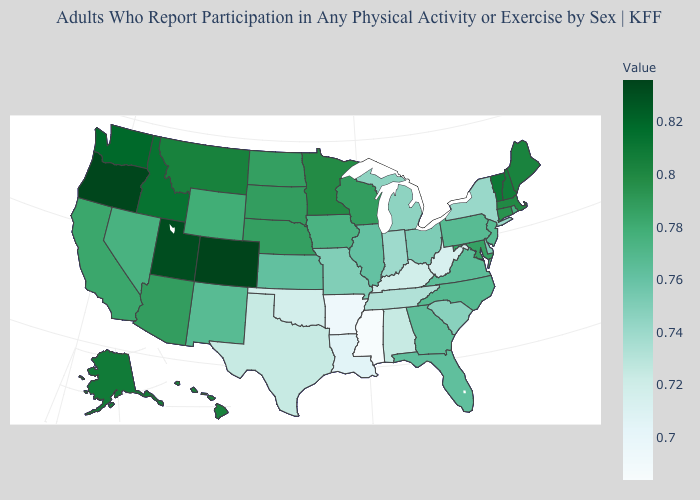Does the map have missing data?
Concise answer only. No. Does Maine have a higher value than Kentucky?
Answer briefly. Yes. Among the states that border Indiana , which have the lowest value?
Keep it brief. Kentucky. Among the states that border Texas , does New Mexico have the highest value?
Quick response, please. Yes. Among the states that border Alabama , does Georgia have the highest value?
Be succinct. Yes. Among the states that border Massachusetts , does Connecticut have the highest value?
Keep it brief. No. Does Vermont have the lowest value in the Northeast?
Concise answer only. No. 